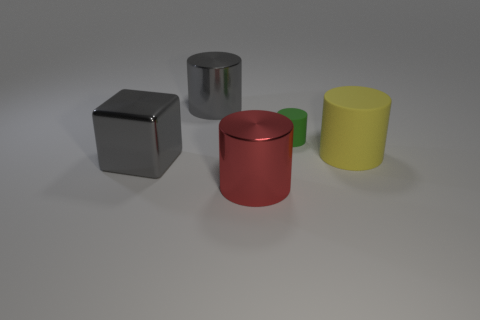Is the size of the metallic block the same as the red shiny cylinder?
Give a very brief answer. Yes. Are there an equal number of small green cylinders right of the large yellow matte object and big shiny cylinders behind the big red cylinder?
Provide a short and direct response. No. There is a big gray thing behind the big yellow object; what is its shape?
Your answer should be very brief. Cylinder. The red metallic thing that is the same size as the gray metallic cube is what shape?
Keep it short and to the point. Cylinder. The shiny cylinder behind the cylinder in front of the big gray shiny object on the left side of the gray shiny cylinder is what color?
Make the answer very short. Gray. Is the large rubber object the same shape as the large red shiny object?
Provide a succinct answer. Yes. Are there the same number of large metal objects that are behind the yellow rubber cylinder and tiny green rubber cylinders?
Your response must be concise. Yes. What number of other objects are there of the same material as the tiny object?
Give a very brief answer. 1. Is the size of the matte cylinder behind the big yellow cylinder the same as the gray object that is behind the gray cube?
Provide a short and direct response. No. How many objects are gray shiny things behind the big matte cylinder or large shiny things behind the tiny matte cylinder?
Offer a very short reply. 1. 